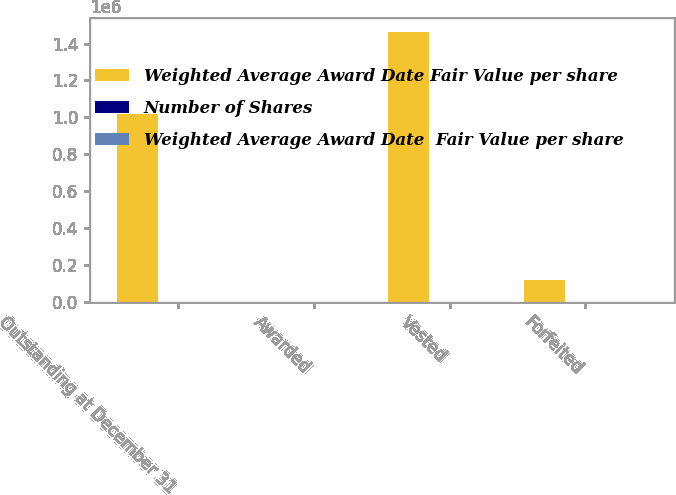Convert chart to OTSL. <chart><loc_0><loc_0><loc_500><loc_500><stacked_bar_chart><ecel><fcel>Outstanding at December 31<fcel>Awarded<fcel>Vested<fcel>Forfeited<nl><fcel>Weighted Average Award Date Fair Value per share<fcel>1.01947e+06<fcel>46.06<fcel>1.46437e+06<fcel>118958<nl><fcel>Number of Shares<fcel>45.55<fcel>39.57<fcel>46.57<fcel>51.36<nl><fcel>Weighted Average Award Date  Fair Value per share<fcel>28.5<fcel>27.3<fcel>42.21<fcel>28.41<nl></chart> 